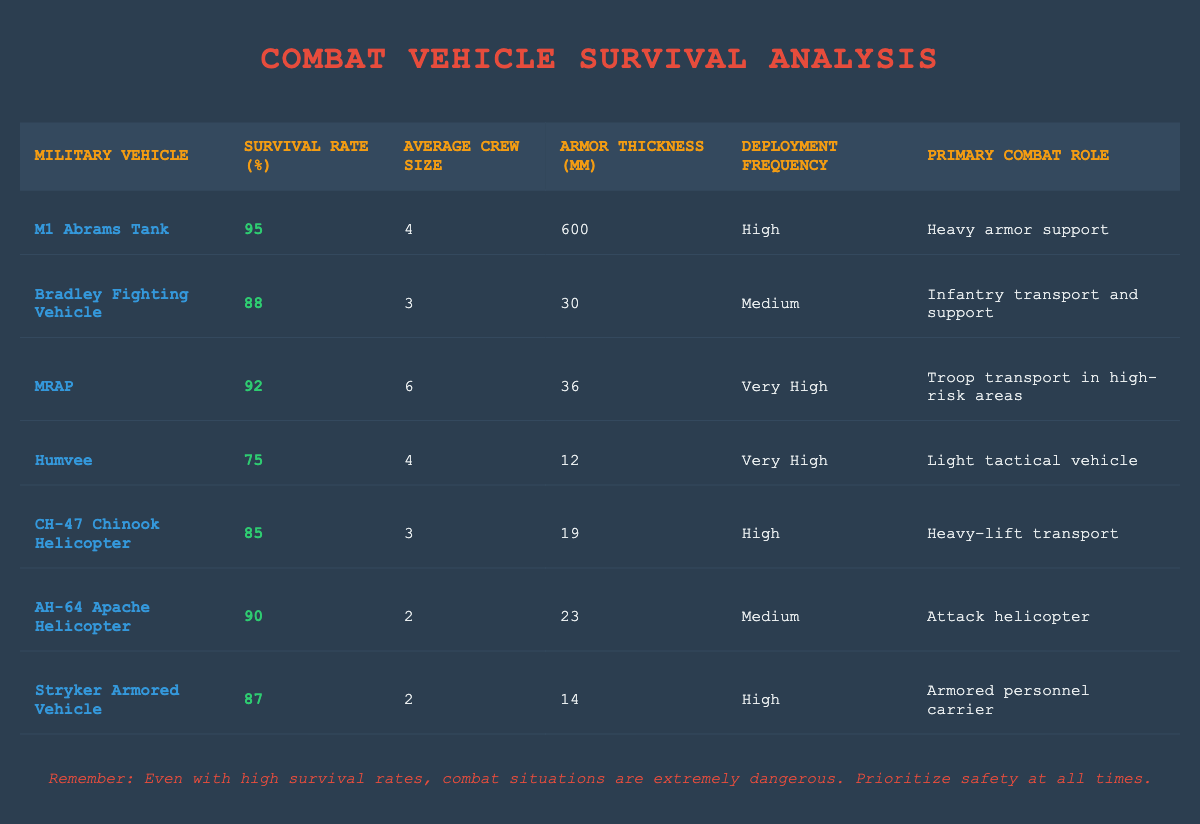What is the survival rate of the M1 Abrams Tank? The survival rate is directly listed in the table, under "Survival Rate (%)" for the M1 Abrams Tank row. It reads 95.
Answer: 95 Which vehicle has the highest armor thickness? To find the vehicle with the highest armor thickness, compare the values listed under "Armor Thickness (mm)" for each vehicle. The M1 Abrams Tank has 600 mm, which is greater than the others.
Answer: M1 Abrams Tank Is the CH-47 Chinook Helicopter's survival rate higher than that of the Bradley Fighting Vehicle? The survival rate for the CH-47 Chinook Helicopter is 85%, while the Bradley Fighting Vehicle's survival rate is 88%. Since 85 is less than 88, the statement is false.
Answer: No What is the average survival rate of the helicopters listed? The survival rates of the helicopters are 85 (CH-47 Chinook) and 90 (AH-64 Apache). To find the average, sum these two rates (85 + 90 = 175) and divide by 2 (175 / 2 = 87.5).
Answer: 87.5 How many vehicles have a survival rate of 90% or higher? Look at the table and count the vehicles with survival rates of 90% or more: M1 Abrams Tank (95%), MRAP (92%), AH-64 Apache (90%), totaling three vehicles.
Answer: 3 Which vehicle has the lowest average crew size? Inspect the "Average Crew Size" column to determine which vehicle has the lowest value. The AH-64 Apache Helicopter has an average crew size of 2, making it the smallest crewed vehicle on the list.
Answer: AH-64 Apache Helicopter Is the average armor thickness of all vehicles more than 100 mm? To find the average armor thickness, sum the values (600 + 30 + 36 + 12 + 19 + 23 + 14 = 734) and divide by the number of vehicles (734 / 7 = 104.86). Since 104.86 is more than 100, the statement is true.
Answer: Yes Which vehicle has a deployment frequency classified as "Very High" and what is its survival rate? The vehicles with "Very High" deployment frequency are the MRAP and the Humvee. The MRAP has a survival rate of 92%, while the Humvee has a survival rate of 75%.
Answer: MRAP: 92%, Humvee: 75% What is the difference in survival rates between the M1 Abrams Tank and the Humvee? The M1 Abrams Tank has a survival rate of 95%, and the Humvee has 75%. The difference is calculated by subtracting the Humvee's rate from the Tank's (95 - 75 = 20).
Answer: 20 